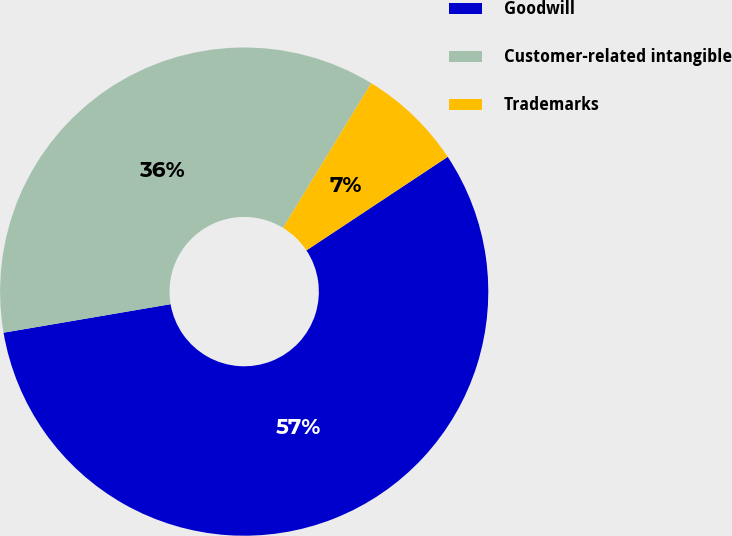Convert chart. <chart><loc_0><loc_0><loc_500><loc_500><pie_chart><fcel>Goodwill<fcel>Customer-related intangible<fcel>Trademarks<nl><fcel>56.62%<fcel>36.4%<fcel>6.98%<nl></chart> 